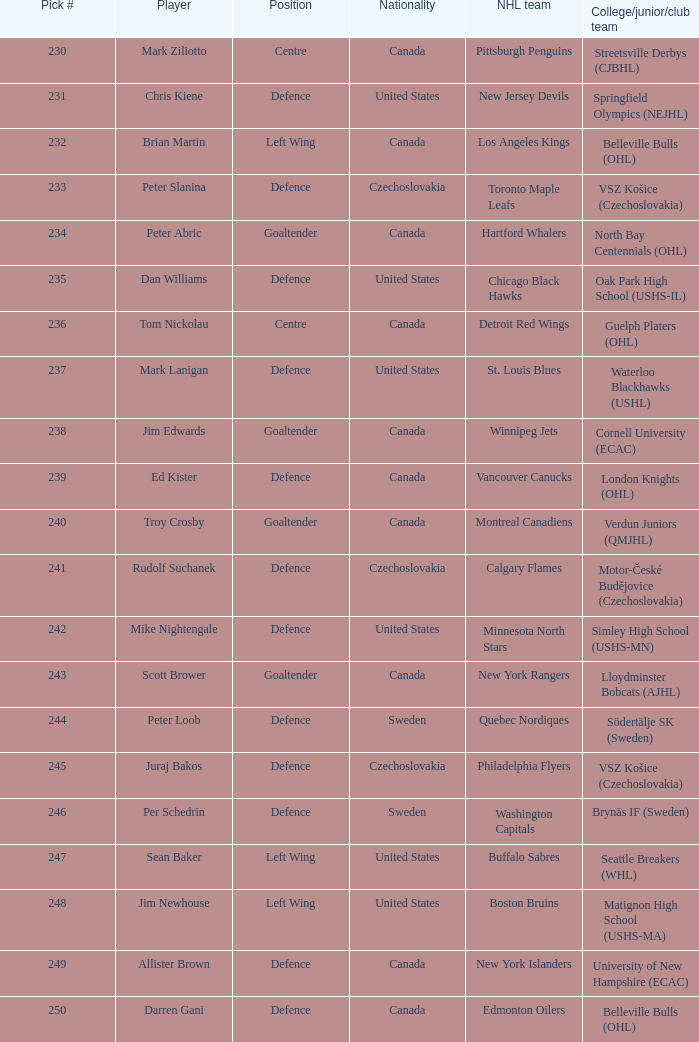To which organziation does the  winnipeg jets belong to? Cornell University (ECAC). 